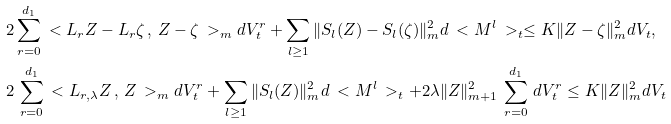Convert formula to latex. <formula><loc_0><loc_0><loc_500><loc_500>& 2 \sum _ { r = 0 } ^ { d _ { 1 } } \ < L _ { r } Z - L _ { r } \zeta \, , \, Z - \zeta \ > _ { m } d V ^ { r } _ { t } + \sum _ { l \geq 1 } \| S _ { l } ( Z ) - S _ { l } ( \zeta ) \| _ { m } ^ { 2 } d \ < M ^ { l } \ > _ { t } \leq K \| Z - \zeta \| _ { m } ^ { 2 } d V _ { t } , \\ & 2 \, \sum _ { r = 0 } ^ { d _ { 1 } } \ < L _ { r , \lambda } Z \, , \, Z \ > _ { m } d V ^ { r } _ { t } + \sum _ { l \geq 1 } \| S _ { l } ( Z ) \| _ { m } ^ { 2 } d \ < M ^ { l } \ > _ { t } + 2 \lambda \| Z \| _ { m + 1 } ^ { 2 } \, \sum _ { r = 0 } ^ { d _ { 1 } } \, d V ^ { r } _ { t } \leq K \| Z \| _ { m } ^ { 2 } d V _ { t }</formula> 